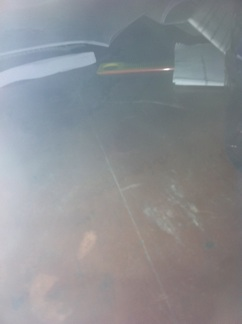If this table could talk, what stories might it tell about its past? If the table could talk, it might tell stories of late-night study sessions, intense discussions, and quiet moments of reflection. It might have witnessed countless pages turned, ideas penned down, and secrets kept. Perhaps it was a favorite spot for someone’s creative pursuits or a reliable surface for daily tasks. Have there been any significant events that took place on this table? The table might have been a part of many significant events, such as the signing of important documents, the sketching of innovative designs, or heartfelt conversations. It could narrate tales of collaboration and solitary work, both contributing to its history. 